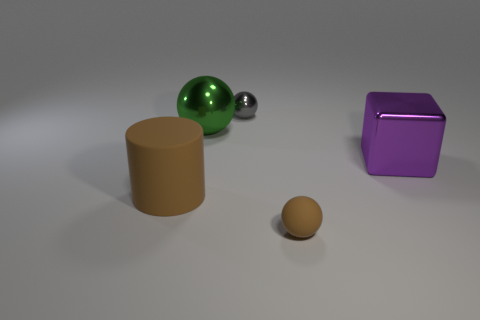Add 2 cubes. How many objects exist? 7 Subtract all red cylinders. Subtract all yellow balls. How many cylinders are left? 1 Subtract all spheres. How many objects are left? 2 Add 1 big brown matte things. How many big brown matte things exist? 2 Subtract 1 purple cubes. How many objects are left? 4 Subtract all gray shiny objects. Subtract all small metallic things. How many objects are left? 3 Add 4 big shiny things. How many big shiny things are left? 6 